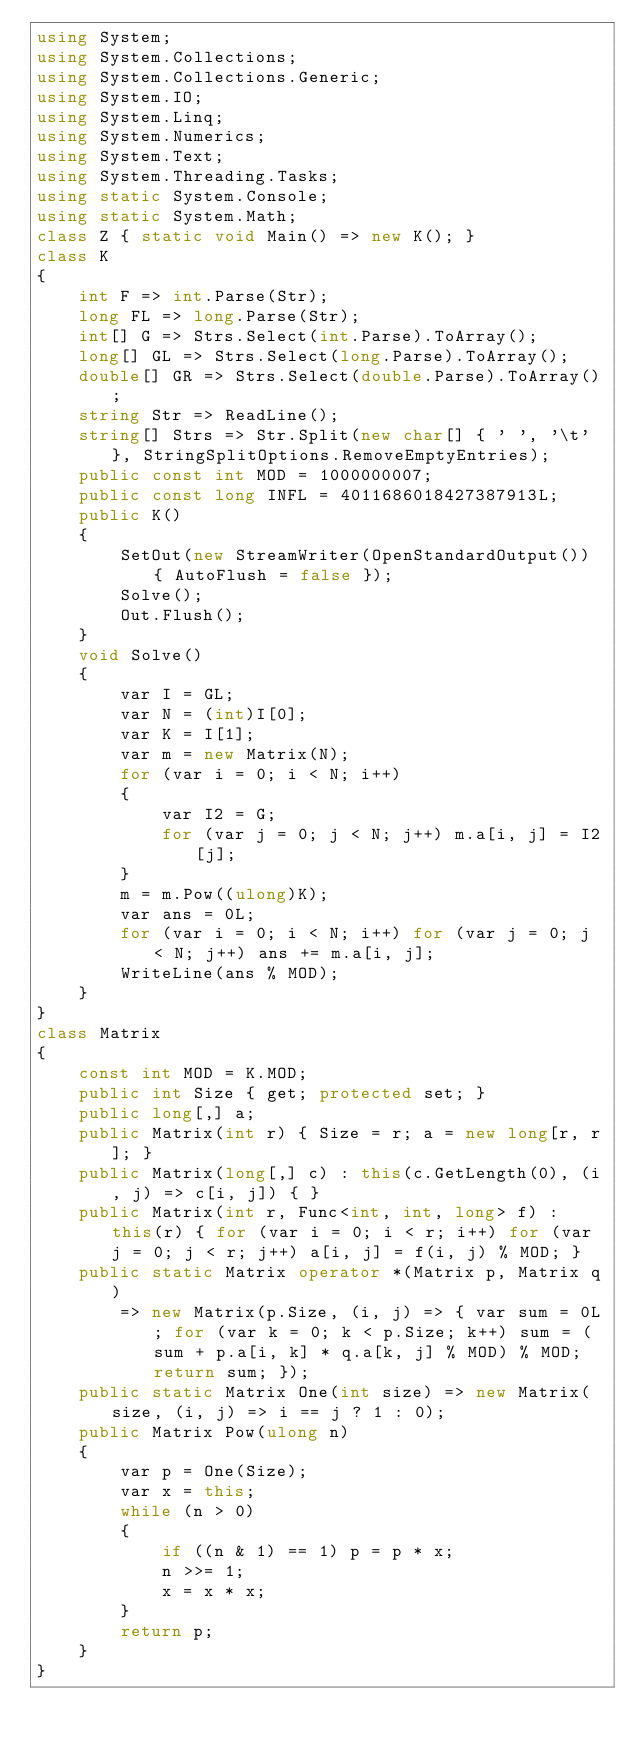<code> <loc_0><loc_0><loc_500><loc_500><_C#_>using System;
using System.Collections;
using System.Collections.Generic;
using System.IO;
using System.Linq;
using System.Numerics;
using System.Text;
using System.Threading.Tasks;
using static System.Console;
using static System.Math;
class Z { static void Main() => new K(); }
class K
{
	int F => int.Parse(Str);
	long FL => long.Parse(Str);
	int[] G => Strs.Select(int.Parse).ToArray();
	long[] GL => Strs.Select(long.Parse).ToArray();
	double[] GR => Strs.Select(double.Parse).ToArray();
	string Str => ReadLine();
	string[] Strs => Str.Split(new char[] { ' ', '\t' }, StringSplitOptions.RemoveEmptyEntries);
	public const int MOD = 1000000007;
	public const long INFL = 4011686018427387913L;
	public K()
	{
		SetOut(new StreamWriter(OpenStandardOutput()) { AutoFlush = false });
		Solve();
		Out.Flush();
	}
	void Solve()
	{
		var I = GL;
		var N = (int)I[0];
		var K = I[1];
		var m = new Matrix(N);
		for (var i = 0; i < N; i++)
		{
			var I2 = G;
			for (var j = 0; j < N; j++) m.a[i, j] = I2[j];
		}
		m = m.Pow((ulong)K);
		var ans = 0L;
		for (var i = 0; i < N; i++) for (var j = 0; j < N; j++) ans += m.a[i, j];
		WriteLine(ans % MOD);
	}
}
class Matrix
{
	const int MOD = K.MOD;
	public int Size { get; protected set; }
	public long[,] a;
	public Matrix(int r) { Size = r; a = new long[r, r]; }
	public Matrix(long[,] c) : this(c.GetLength(0), (i, j) => c[i, j]) { }
	public Matrix(int r, Func<int, int, long> f) : this(r) { for (var i = 0; i < r; i++) for (var j = 0; j < r; j++) a[i, j] = f(i, j) % MOD; }
	public static Matrix operator *(Matrix p, Matrix q)
		=> new Matrix(p.Size, (i, j) => { var sum = 0L; for (var k = 0; k < p.Size; k++) sum = (sum + p.a[i, k] * q.a[k, j] % MOD) % MOD; return sum; });
	public static Matrix One(int size) => new Matrix(size, (i, j) => i == j ? 1 : 0);
	public Matrix Pow(ulong n)
	{
		var p = One(Size);
		var x = this;
		while (n > 0)
		{
			if ((n & 1) == 1) p = p * x;
			n >>= 1;
			x = x * x;
		}
		return p;
	}
}</code> 